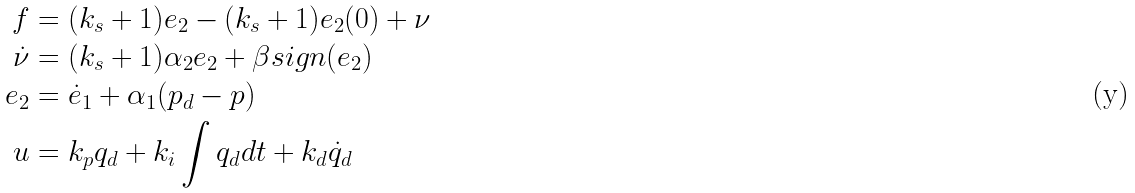Convert formula to latex. <formula><loc_0><loc_0><loc_500><loc_500>f & = ( k _ { s } + 1 ) e _ { 2 } - ( k _ { s } + 1 ) e _ { 2 } ( 0 ) + \nu \\ \dot { \nu } & = ( k _ { s } + 1 ) \alpha _ { 2 } e _ { 2 } + \beta s i g n ( e _ { 2 } ) \\ e _ { 2 } & = \dot { e } _ { 1 } + \alpha _ { 1 } ( p _ { d } - p ) \\ u & = k _ { p } q _ { d } + k _ { i } \int q _ { d } d t + k _ { d } \dot { q } _ { d }</formula> 